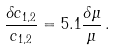<formula> <loc_0><loc_0><loc_500><loc_500>\frac { \delta c _ { 1 , 2 } } { c _ { 1 , 2 } } = 5 . 1 \frac { \delta \mu } { \mu } \, .</formula> 